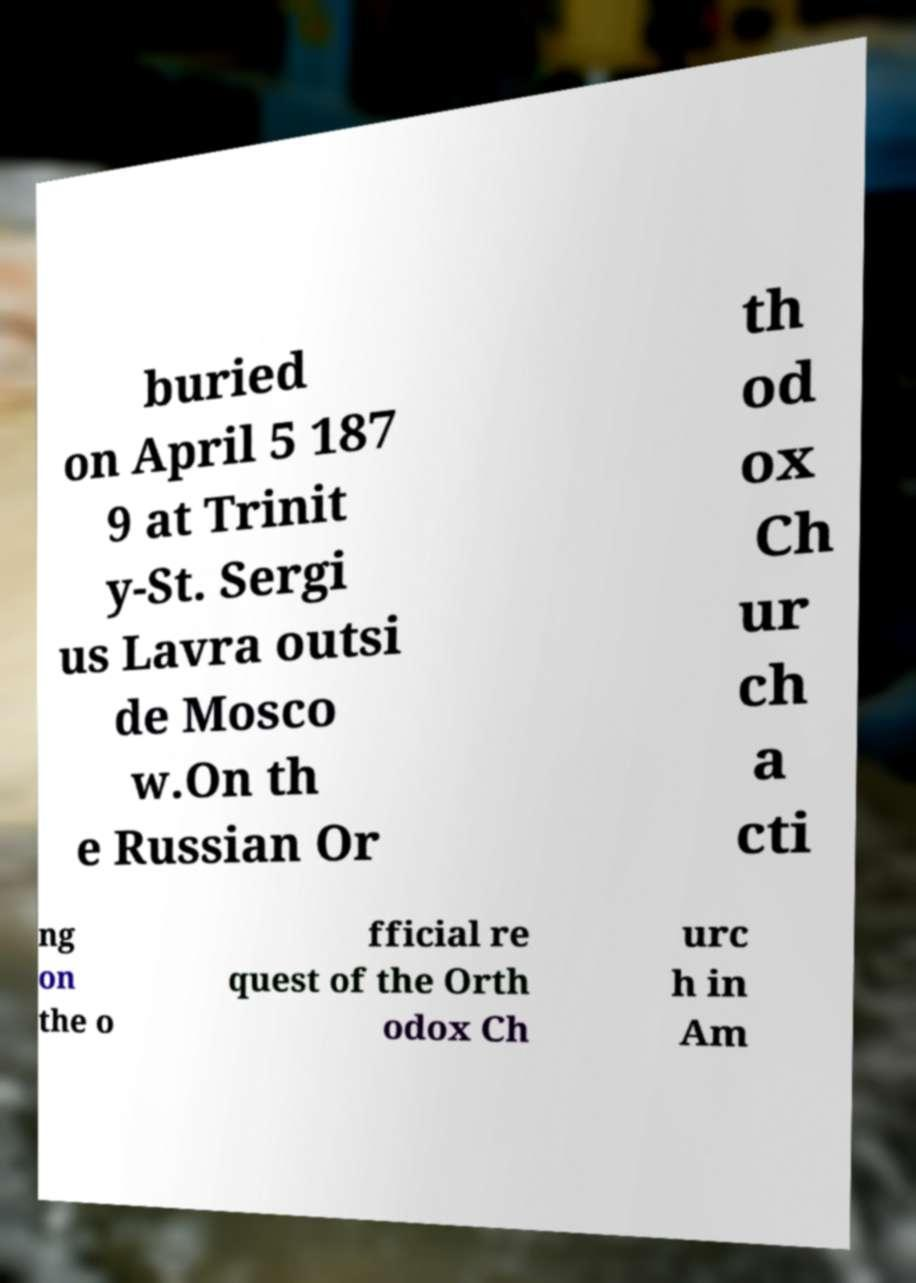Please read and relay the text visible in this image. What does it say? buried on April 5 187 9 at Trinit y-St. Sergi us Lavra outsi de Mosco w.On th e Russian Or th od ox Ch ur ch a cti ng on the o fficial re quest of the Orth odox Ch urc h in Am 